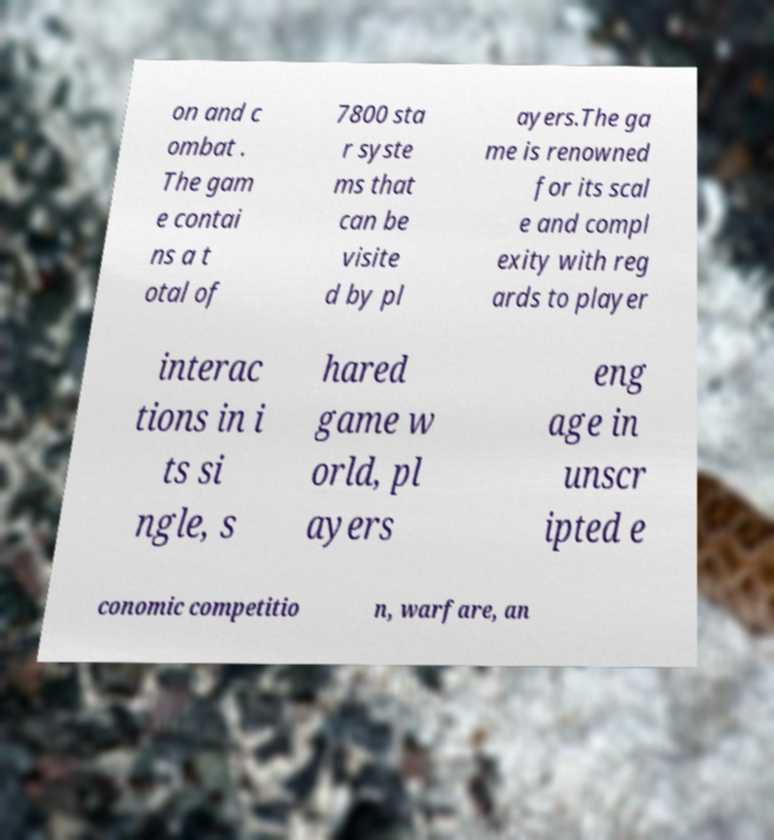Could you assist in decoding the text presented in this image and type it out clearly? on and c ombat . The gam e contai ns a t otal of 7800 sta r syste ms that can be visite d by pl ayers.The ga me is renowned for its scal e and compl exity with reg ards to player interac tions in i ts si ngle, s hared game w orld, pl ayers eng age in unscr ipted e conomic competitio n, warfare, an 